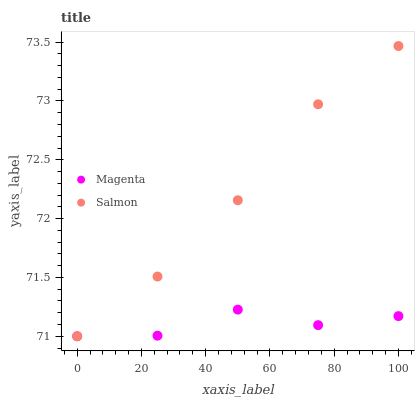Does Magenta have the minimum area under the curve?
Answer yes or no. Yes. Does Salmon have the maximum area under the curve?
Answer yes or no. Yes. Does Salmon have the minimum area under the curve?
Answer yes or no. No. Is Salmon the smoothest?
Answer yes or no. Yes. Is Magenta the roughest?
Answer yes or no. Yes. Is Salmon the roughest?
Answer yes or no. No. Does Magenta have the lowest value?
Answer yes or no. Yes. Does Salmon have the highest value?
Answer yes or no. Yes. Does Salmon intersect Magenta?
Answer yes or no. Yes. Is Salmon less than Magenta?
Answer yes or no. No. Is Salmon greater than Magenta?
Answer yes or no. No. 